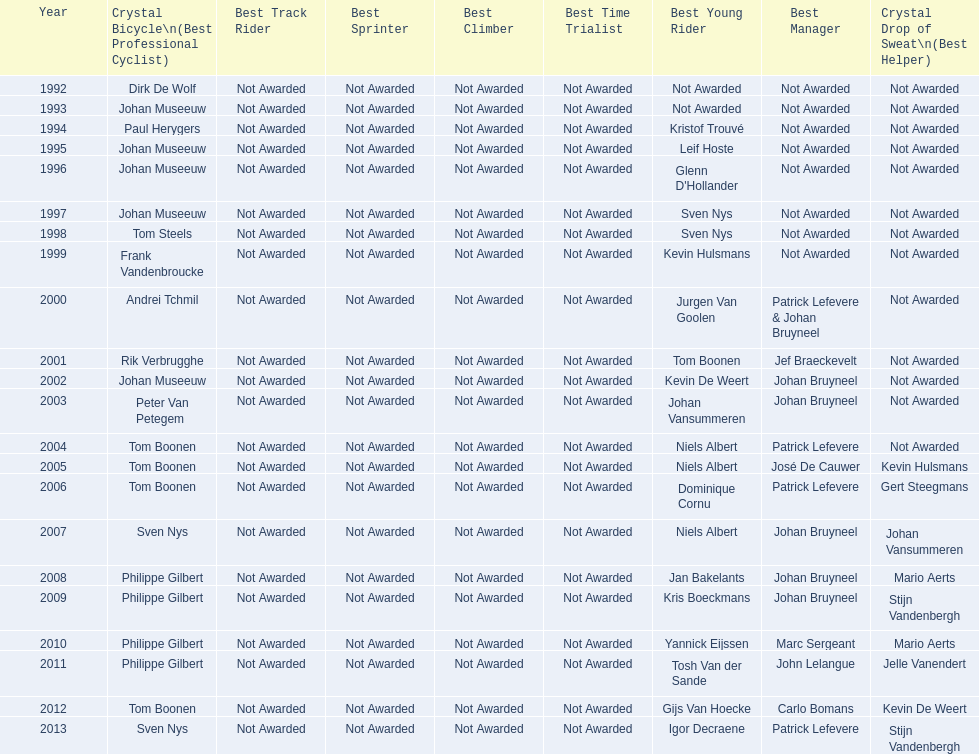Who won the crystal bicycle earlier, boonen or nys? Tom Boonen. 